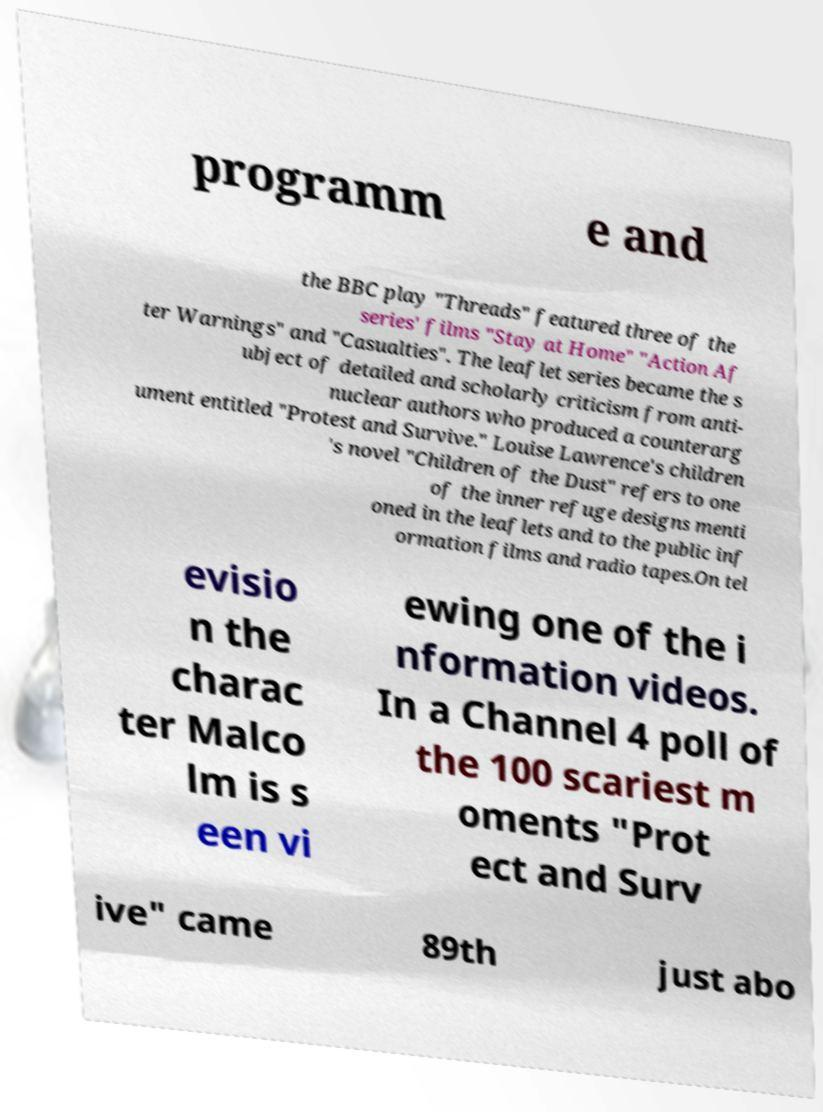Can you accurately transcribe the text from the provided image for me? programm e and the BBC play "Threads" featured three of the series' films "Stay at Home" "Action Af ter Warnings" and "Casualties". The leaflet series became the s ubject of detailed and scholarly criticism from anti- nuclear authors who produced a counterarg ument entitled "Protest and Survive." Louise Lawrence's children 's novel "Children of the Dust" refers to one of the inner refuge designs menti oned in the leaflets and to the public inf ormation films and radio tapes.On tel evisio n the charac ter Malco lm is s een vi ewing one of the i nformation videos. In a Channel 4 poll of the 100 scariest m oments "Prot ect and Surv ive" came 89th just abo 